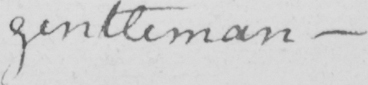Please transcribe the handwritten text in this image. gentleman - 